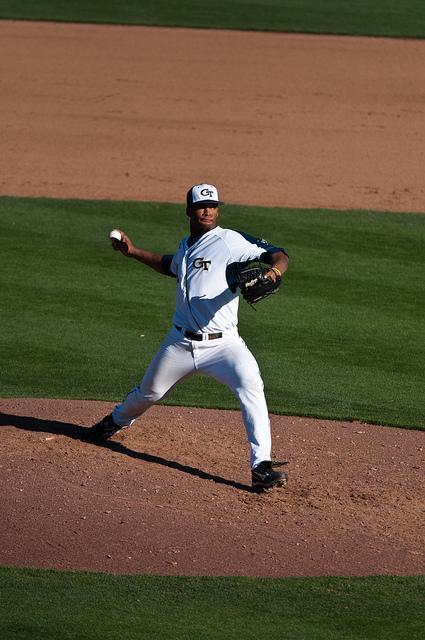How many field positions are visible in this picture?
Give a very brief answer. 1. 